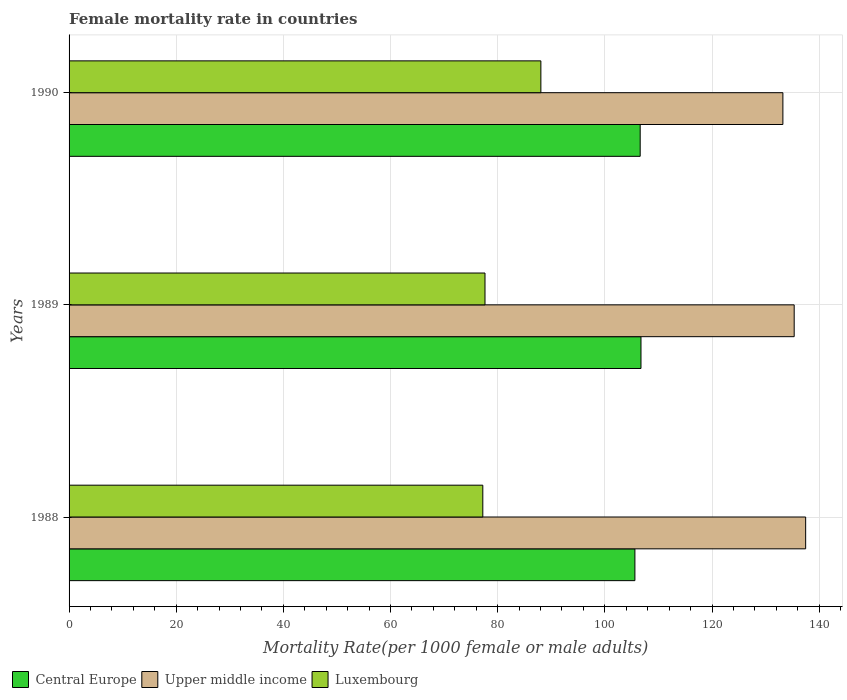Are the number of bars on each tick of the Y-axis equal?
Give a very brief answer. Yes. How many bars are there on the 1st tick from the top?
Your answer should be compact. 3. What is the label of the 2nd group of bars from the top?
Provide a short and direct response. 1989. In how many cases, is the number of bars for a given year not equal to the number of legend labels?
Make the answer very short. 0. What is the female mortality rate in Upper middle income in 1990?
Give a very brief answer. 133.23. Across all years, what is the maximum female mortality rate in Upper middle income?
Your answer should be very brief. 137.48. Across all years, what is the minimum female mortality rate in Central Europe?
Make the answer very short. 105.61. In which year was the female mortality rate in Luxembourg maximum?
Your answer should be very brief. 1990. What is the total female mortality rate in Luxembourg in the graph?
Your answer should be very brief. 242.91. What is the difference between the female mortality rate in Central Europe in 1989 and that in 1990?
Offer a terse response. 0.15. What is the difference between the female mortality rate in Upper middle income in 1988 and the female mortality rate in Luxembourg in 1989?
Keep it short and to the point. 59.85. What is the average female mortality rate in Luxembourg per year?
Give a very brief answer. 80.97. In the year 1989, what is the difference between the female mortality rate in Upper middle income and female mortality rate in Central Europe?
Ensure brevity in your answer.  28.6. What is the ratio of the female mortality rate in Luxembourg in 1989 to that in 1990?
Your response must be concise. 0.88. Is the female mortality rate in Luxembourg in 1988 less than that in 1990?
Your response must be concise. Yes. What is the difference between the highest and the second highest female mortality rate in Upper middle income?
Ensure brevity in your answer.  2.14. What is the difference between the highest and the lowest female mortality rate in Central Europe?
Make the answer very short. 1.13. In how many years, is the female mortality rate in Luxembourg greater than the average female mortality rate in Luxembourg taken over all years?
Keep it short and to the point. 1. What does the 1st bar from the top in 1989 represents?
Offer a very short reply. Luxembourg. What does the 3rd bar from the bottom in 1989 represents?
Your answer should be compact. Luxembourg. Are all the bars in the graph horizontal?
Your response must be concise. Yes. Does the graph contain any zero values?
Give a very brief answer. No. What is the title of the graph?
Your answer should be compact. Female mortality rate in countries. What is the label or title of the X-axis?
Ensure brevity in your answer.  Mortality Rate(per 1000 female or male adults). What is the Mortality Rate(per 1000 female or male adults) of Central Europe in 1988?
Your response must be concise. 105.61. What is the Mortality Rate(per 1000 female or male adults) in Upper middle income in 1988?
Give a very brief answer. 137.48. What is the Mortality Rate(per 1000 female or male adults) in Luxembourg in 1988?
Offer a very short reply. 77.22. What is the Mortality Rate(per 1000 female or male adults) in Central Europe in 1989?
Give a very brief answer. 106.74. What is the Mortality Rate(per 1000 female or male adults) of Upper middle income in 1989?
Keep it short and to the point. 135.34. What is the Mortality Rate(per 1000 female or male adults) in Luxembourg in 1989?
Your answer should be compact. 77.63. What is the Mortality Rate(per 1000 female or male adults) in Central Europe in 1990?
Provide a short and direct response. 106.6. What is the Mortality Rate(per 1000 female or male adults) of Upper middle income in 1990?
Provide a short and direct response. 133.23. What is the Mortality Rate(per 1000 female or male adults) of Luxembourg in 1990?
Your answer should be very brief. 88.06. Across all years, what is the maximum Mortality Rate(per 1000 female or male adults) in Central Europe?
Provide a short and direct response. 106.74. Across all years, what is the maximum Mortality Rate(per 1000 female or male adults) of Upper middle income?
Offer a terse response. 137.48. Across all years, what is the maximum Mortality Rate(per 1000 female or male adults) of Luxembourg?
Your response must be concise. 88.06. Across all years, what is the minimum Mortality Rate(per 1000 female or male adults) of Central Europe?
Your answer should be compact. 105.61. Across all years, what is the minimum Mortality Rate(per 1000 female or male adults) of Upper middle income?
Your response must be concise. 133.23. Across all years, what is the minimum Mortality Rate(per 1000 female or male adults) in Luxembourg?
Offer a terse response. 77.22. What is the total Mortality Rate(per 1000 female or male adults) of Central Europe in the graph?
Make the answer very short. 318.95. What is the total Mortality Rate(per 1000 female or male adults) of Upper middle income in the graph?
Your answer should be compact. 406.05. What is the total Mortality Rate(per 1000 female or male adults) in Luxembourg in the graph?
Keep it short and to the point. 242.91. What is the difference between the Mortality Rate(per 1000 female or male adults) in Central Europe in 1988 and that in 1989?
Your answer should be compact. -1.13. What is the difference between the Mortality Rate(per 1000 female or male adults) in Upper middle income in 1988 and that in 1989?
Provide a short and direct response. 2.14. What is the difference between the Mortality Rate(per 1000 female or male adults) in Luxembourg in 1988 and that in 1989?
Your answer should be compact. -0.41. What is the difference between the Mortality Rate(per 1000 female or male adults) in Central Europe in 1988 and that in 1990?
Your response must be concise. -0.99. What is the difference between the Mortality Rate(per 1000 female or male adults) in Upper middle income in 1988 and that in 1990?
Keep it short and to the point. 4.25. What is the difference between the Mortality Rate(per 1000 female or male adults) in Luxembourg in 1988 and that in 1990?
Ensure brevity in your answer.  -10.84. What is the difference between the Mortality Rate(per 1000 female or male adults) in Central Europe in 1989 and that in 1990?
Offer a terse response. 0.15. What is the difference between the Mortality Rate(per 1000 female or male adults) of Upper middle income in 1989 and that in 1990?
Keep it short and to the point. 2.11. What is the difference between the Mortality Rate(per 1000 female or male adults) in Luxembourg in 1989 and that in 1990?
Keep it short and to the point. -10.43. What is the difference between the Mortality Rate(per 1000 female or male adults) in Central Europe in 1988 and the Mortality Rate(per 1000 female or male adults) in Upper middle income in 1989?
Your answer should be very brief. -29.73. What is the difference between the Mortality Rate(per 1000 female or male adults) of Central Europe in 1988 and the Mortality Rate(per 1000 female or male adults) of Luxembourg in 1989?
Give a very brief answer. 27.98. What is the difference between the Mortality Rate(per 1000 female or male adults) in Upper middle income in 1988 and the Mortality Rate(per 1000 female or male adults) in Luxembourg in 1989?
Provide a short and direct response. 59.85. What is the difference between the Mortality Rate(per 1000 female or male adults) of Central Europe in 1988 and the Mortality Rate(per 1000 female or male adults) of Upper middle income in 1990?
Make the answer very short. -27.62. What is the difference between the Mortality Rate(per 1000 female or male adults) in Central Europe in 1988 and the Mortality Rate(per 1000 female or male adults) in Luxembourg in 1990?
Give a very brief answer. 17.55. What is the difference between the Mortality Rate(per 1000 female or male adults) of Upper middle income in 1988 and the Mortality Rate(per 1000 female or male adults) of Luxembourg in 1990?
Your answer should be very brief. 49.42. What is the difference between the Mortality Rate(per 1000 female or male adults) of Central Europe in 1989 and the Mortality Rate(per 1000 female or male adults) of Upper middle income in 1990?
Your answer should be compact. -26.49. What is the difference between the Mortality Rate(per 1000 female or male adults) of Central Europe in 1989 and the Mortality Rate(per 1000 female or male adults) of Luxembourg in 1990?
Offer a very short reply. 18.68. What is the difference between the Mortality Rate(per 1000 female or male adults) in Upper middle income in 1989 and the Mortality Rate(per 1000 female or male adults) in Luxembourg in 1990?
Make the answer very short. 47.28. What is the average Mortality Rate(per 1000 female or male adults) of Central Europe per year?
Offer a very short reply. 106.32. What is the average Mortality Rate(per 1000 female or male adults) of Upper middle income per year?
Provide a short and direct response. 135.35. What is the average Mortality Rate(per 1000 female or male adults) in Luxembourg per year?
Keep it short and to the point. 80.97. In the year 1988, what is the difference between the Mortality Rate(per 1000 female or male adults) in Central Europe and Mortality Rate(per 1000 female or male adults) in Upper middle income?
Offer a very short reply. -31.87. In the year 1988, what is the difference between the Mortality Rate(per 1000 female or male adults) of Central Europe and Mortality Rate(per 1000 female or male adults) of Luxembourg?
Ensure brevity in your answer.  28.39. In the year 1988, what is the difference between the Mortality Rate(per 1000 female or male adults) in Upper middle income and Mortality Rate(per 1000 female or male adults) in Luxembourg?
Ensure brevity in your answer.  60.26. In the year 1989, what is the difference between the Mortality Rate(per 1000 female or male adults) in Central Europe and Mortality Rate(per 1000 female or male adults) in Upper middle income?
Offer a very short reply. -28.6. In the year 1989, what is the difference between the Mortality Rate(per 1000 female or male adults) of Central Europe and Mortality Rate(per 1000 female or male adults) of Luxembourg?
Keep it short and to the point. 29.11. In the year 1989, what is the difference between the Mortality Rate(per 1000 female or male adults) in Upper middle income and Mortality Rate(per 1000 female or male adults) in Luxembourg?
Give a very brief answer. 57.71. In the year 1990, what is the difference between the Mortality Rate(per 1000 female or male adults) in Central Europe and Mortality Rate(per 1000 female or male adults) in Upper middle income?
Keep it short and to the point. -26.63. In the year 1990, what is the difference between the Mortality Rate(per 1000 female or male adults) of Central Europe and Mortality Rate(per 1000 female or male adults) of Luxembourg?
Make the answer very short. 18.54. In the year 1990, what is the difference between the Mortality Rate(per 1000 female or male adults) of Upper middle income and Mortality Rate(per 1000 female or male adults) of Luxembourg?
Your answer should be compact. 45.17. What is the ratio of the Mortality Rate(per 1000 female or male adults) in Central Europe in 1988 to that in 1989?
Ensure brevity in your answer.  0.99. What is the ratio of the Mortality Rate(per 1000 female or male adults) in Upper middle income in 1988 to that in 1989?
Keep it short and to the point. 1.02. What is the ratio of the Mortality Rate(per 1000 female or male adults) of Central Europe in 1988 to that in 1990?
Give a very brief answer. 0.99. What is the ratio of the Mortality Rate(per 1000 female or male adults) of Upper middle income in 1988 to that in 1990?
Your response must be concise. 1.03. What is the ratio of the Mortality Rate(per 1000 female or male adults) in Luxembourg in 1988 to that in 1990?
Your answer should be very brief. 0.88. What is the ratio of the Mortality Rate(per 1000 female or male adults) in Upper middle income in 1989 to that in 1990?
Offer a very short reply. 1.02. What is the ratio of the Mortality Rate(per 1000 female or male adults) in Luxembourg in 1989 to that in 1990?
Your answer should be compact. 0.88. What is the difference between the highest and the second highest Mortality Rate(per 1000 female or male adults) of Central Europe?
Provide a short and direct response. 0.15. What is the difference between the highest and the second highest Mortality Rate(per 1000 female or male adults) of Upper middle income?
Make the answer very short. 2.14. What is the difference between the highest and the second highest Mortality Rate(per 1000 female or male adults) of Luxembourg?
Provide a short and direct response. 10.43. What is the difference between the highest and the lowest Mortality Rate(per 1000 female or male adults) of Central Europe?
Offer a very short reply. 1.13. What is the difference between the highest and the lowest Mortality Rate(per 1000 female or male adults) of Upper middle income?
Ensure brevity in your answer.  4.25. What is the difference between the highest and the lowest Mortality Rate(per 1000 female or male adults) of Luxembourg?
Give a very brief answer. 10.84. 